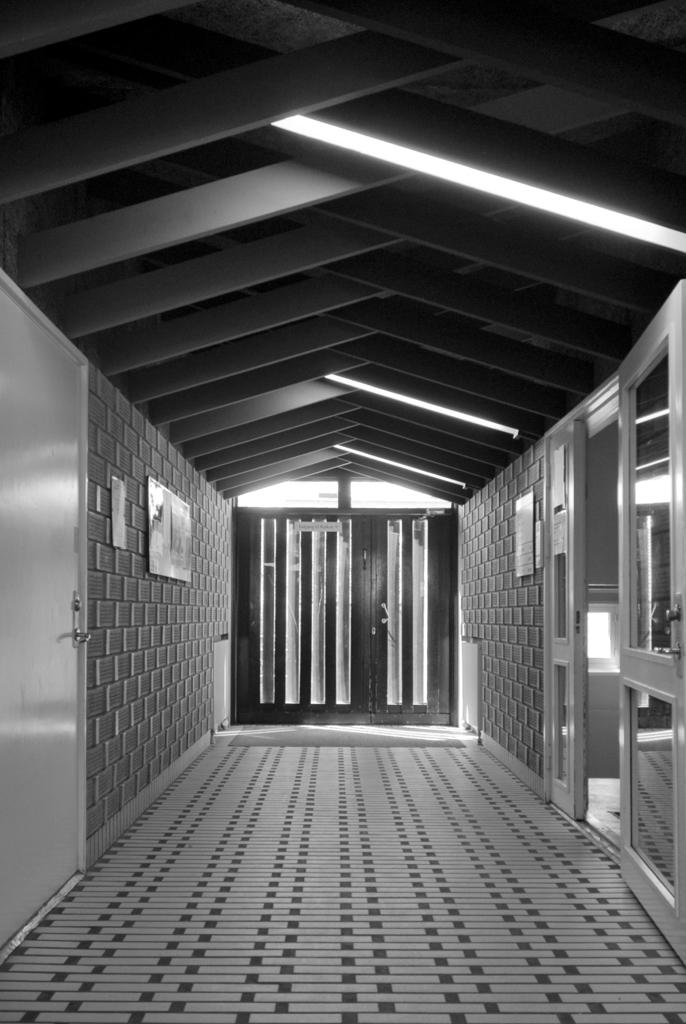What type of location is depicted in the image? The image shows the inside of a house. What structural elements can be seen in the image? There are walls visible in the image. Are there any passageways to other rooms in the image? Yes, there are doors to other rooms on either side. What is visible in the background of the image? There is a door visible in the background. What type of lighting is present in the image? Lights are present on the ceiling. What type of shoe can be seen floating in space in the image? There is no shoe or space present in the image; it depicts the inside of a house with walls, doors, and ceiling lights. 